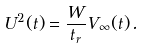Convert formula to latex. <formula><loc_0><loc_0><loc_500><loc_500>U ^ { 2 } ( t ) = \frac { W } { t _ { r } } V _ { \infty } ( t ) \, .</formula> 